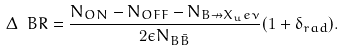Convert formula to latex. <formula><loc_0><loc_0><loc_500><loc_500>\Delta \ B R = \frac { N _ { O N } - N _ { O F F } - N _ { B \nrightarrow X _ { u } e \nu } } { 2 \epsilon N _ { B \bar { B } } } ( 1 + \delta _ { r a d } ) .</formula> 